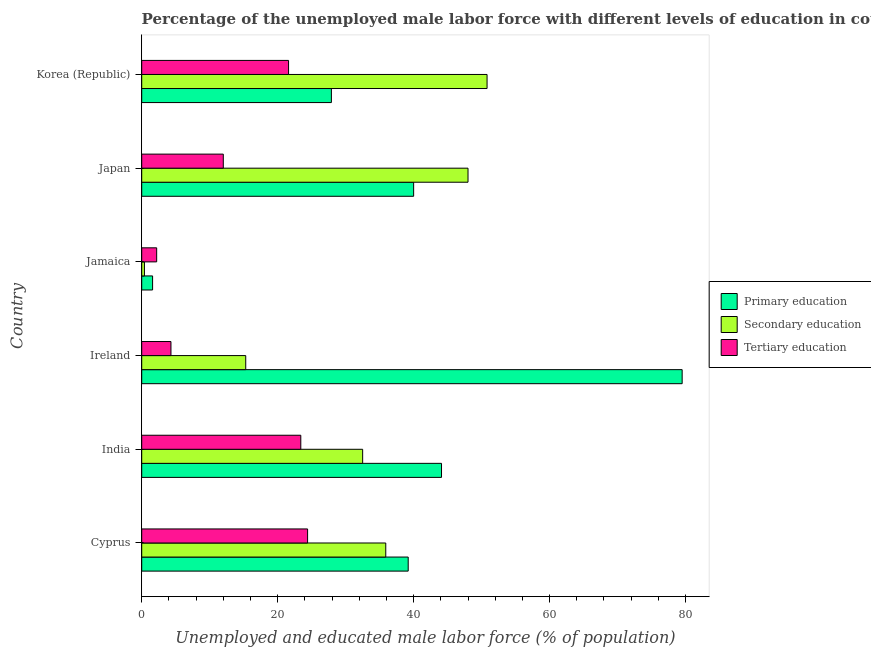How many different coloured bars are there?
Your response must be concise. 3. How many groups of bars are there?
Offer a very short reply. 6. Are the number of bars per tick equal to the number of legend labels?
Provide a succinct answer. Yes. Are the number of bars on each tick of the Y-axis equal?
Provide a succinct answer. Yes. How many bars are there on the 2nd tick from the top?
Provide a short and direct response. 3. What is the label of the 4th group of bars from the top?
Offer a very short reply. Ireland. What is the percentage of male labor force who received secondary education in Cyprus?
Provide a succinct answer. 35.9. Across all countries, what is the maximum percentage of male labor force who received secondary education?
Your answer should be very brief. 50.8. Across all countries, what is the minimum percentage of male labor force who received primary education?
Your answer should be very brief. 1.6. In which country was the percentage of male labor force who received tertiary education maximum?
Provide a short and direct response. Cyprus. In which country was the percentage of male labor force who received primary education minimum?
Your response must be concise. Jamaica. What is the total percentage of male labor force who received tertiary education in the graph?
Your response must be concise. 87.9. What is the difference between the percentage of male labor force who received tertiary education in Japan and the percentage of male labor force who received primary education in Jamaica?
Your answer should be compact. 10.4. What is the average percentage of male labor force who received tertiary education per country?
Ensure brevity in your answer.  14.65. In how many countries, is the percentage of male labor force who received primary education greater than 72 %?
Provide a succinct answer. 1. What is the ratio of the percentage of male labor force who received secondary education in Jamaica to that in Japan?
Offer a very short reply. 0.01. Is the difference between the percentage of male labor force who received tertiary education in Cyprus and Ireland greater than the difference between the percentage of male labor force who received primary education in Cyprus and Ireland?
Keep it short and to the point. Yes. What is the difference between the highest and the second highest percentage of male labor force who received primary education?
Offer a very short reply. 35.4. What is the difference between the highest and the lowest percentage of male labor force who received tertiary education?
Your response must be concise. 22.2. Is the sum of the percentage of male labor force who received primary education in Cyprus and Japan greater than the maximum percentage of male labor force who received tertiary education across all countries?
Your answer should be very brief. Yes. What does the 2nd bar from the top in India represents?
Provide a short and direct response. Secondary education. Is it the case that in every country, the sum of the percentage of male labor force who received primary education and percentage of male labor force who received secondary education is greater than the percentage of male labor force who received tertiary education?
Offer a very short reply. No. How many bars are there?
Give a very brief answer. 18. Are all the bars in the graph horizontal?
Your response must be concise. Yes. How many countries are there in the graph?
Give a very brief answer. 6. What is the difference between two consecutive major ticks on the X-axis?
Your answer should be compact. 20. Does the graph contain any zero values?
Make the answer very short. No. What is the title of the graph?
Ensure brevity in your answer.  Percentage of the unemployed male labor force with different levels of education in countries. Does "Profit Tax" appear as one of the legend labels in the graph?
Give a very brief answer. No. What is the label or title of the X-axis?
Ensure brevity in your answer.  Unemployed and educated male labor force (% of population). What is the label or title of the Y-axis?
Provide a succinct answer. Country. What is the Unemployed and educated male labor force (% of population) in Primary education in Cyprus?
Provide a short and direct response. 39.2. What is the Unemployed and educated male labor force (% of population) in Secondary education in Cyprus?
Offer a terse response. 35.9. What is the Unemployed and educated male labor force (% of population) in Tertiary education in Cyprus?
Provide a short and direct response. 24.4. What is the Unemployed and educated male labor force (% of population) of Primary education in India?
Ensure brevity in your answer.  44.1. What is the Unemployed and educated male labor force (% of population) of Secondary education in India?
Ensure brevity in your answer.  32.5. What is the Unemployed and educated male labor force (% of population) of Tertiary education in India?
Your answer should be very brief. 23.4. What is the Unemployed and educated male labor force (% of population) of Primary education in Ireland?
Your answer should be very brief. 79.5. What is the Unemployed and educated male labor force (% of population) of Secondary education in Ireland?
Make the answer very short. 15.3. What is the Unemployed and educated male labor force (% of population) of Tertiary education in Ireland?
Keep it short and to the point. 4.3. What is the Unemployed and educated male labor force (% of population) of Primary education in Jamaica?
Offer a very short reply. 1.6. What is the Unemployed and educated male labor force (% of population) of Secondary education in Jamaica?
Offer a very short reply. 0.4. What is the Unemployed and educated male labor force (% of population) of Tertiary education in Jamaica?
Your answer should be compact. 2.2. What is the Unemployed and educated male labor force (% of population) in Primary education in Japan?
Keep it short and to the point. 40. What is the Unemployed and educated male labor force (% of population) of Tertiary education in Japan?
Give a very brief answer. 12. What is the Unemployed and educated male labor force (% of population) of Primary education in Korea (Republic)?
Keep it short and to the point. 27.9. What is the Unemployed and educated male labor force (% of population) of Secondary education in Korea (Republic)?
Offer a very short reply. 50.8. What is the Unemployed and educated male labor force (% of population) in Tertiary education in Korea (Republic)?
Your answer should be compact. 21.6. Across all countries, what is the maximum Unemployed and educated male labor force (% of population) in Primary education?
Your answer should be very brief. 79.5. Across all countries, what is the maximum Unemployed and educated male labor force (% of population) of Secondary education?
Provide a short and direct response. 50.8. Across all countries, what is the maximum Unemployed and educated male labor force (% of population) in Tertiary education?
Offer a very short reply. 24.4. Across all countries, what is the minimum Unemployed and educated male labor force (% of population) in Primary education?
Keep it short and to the point. 1.6. Across all countries, what is the minimum Unemployed and educated male labor force (% of population) in Secondary education?
Offer a very short reply. 0.4. Across all countries, what is the minimum Unemployed and educated male labor force (% of population) in Tertiary education?
Offer a terse response. 2.2. What is the total Unemployed and educated male labor force (% of population) of Primary education in the graph?
Provide a succinct answer. 232.3. What is the total Unemployed and educated male labor force (% of population) of Secondary education in the graph?
Your answer should be very brief. 182.9. What is the total Unemployed and educated male labor force (% of population) in Tertiary education in the graph?
Your answer should be very brief. 87.9. What is the difference between the Unemployed and educated male labor force (% of population) in Secondary education in Cyprus and that in India?
Give a very brief answer. 3.4. What is the difference between the Unemployed and educated male labor force (% of population) in Primary education in Cyprus and that in Ireland?
Your answer should be very brief. -40.3. What is the difference between the Unemployed and educated male labor force (% of population) in Secondary education in Cyprus and that in Ireland?
Keep it short and to the point. 20.6. What is the difference between the Unemployed and educated male labor force (% of population) of Tertiary education in Cyprus and that in Ireland?
Offer a very short reply. 20.1. What is the difference between the Unemployed and educated male labor force (% of population) in Primary education in Cyprus and that in Jamaica?
Keep it short and to the point. 37.6. What is the difference between the Unemployed and educated male labor force (% of population) in Secondary education in Cyprus and that in Jamaica?
Your answer should be compact. 35.5. What is the difference between the Unemployed and educated male labor force (% of population) in Tertiary education in Cyprus and that in Jamaica?
Your answer should be very brief. 22.2. What is the difference between the Unemployed and educated male labor force (% of population) of Secondary education in Cyprus and that in Japan?
Provide a succinct answer. -12.1. What is the difference between the Unemployed and educated male labor force (% of population) in Tertiary education in Cyprus and that in Japan?
Provide a succinct answer. 12.4. What is the difference between the Unemployed and educated male labor force (% of population) in Secondary education in Cyprus and that in Korea (Republic)?
Provide a short and direct response. -14.9. What is the difference between the Unemployed and educated male labor force (% of population) of Primary education in India and that in Ireland?
Offer a very short reply. -35.4. What is the difference between the Unemployed and educated male labor force (% of population) in Secondary education in India and that in Ireland?
Keep it short and to the point. 17.2. What is the difference between the Unemployed and educated male labor force (% of population) in Primary education in India and that in Jamaica?
Offer a very short reply. 42.5. What is the difference between the Unemployed and educated male labor force (% of population) of Secondary education in India and that in Jamaica?
Provide a short and direct response. 32.1. What is the difference between the Unemployed and educated male labor force (% of population) in Tertiary education in India and that in Jamaica?
Offer a very short reply. 21.2. What is the difference between the Unemployed and educated male labor force (% of population) in Secondary education in India and that in Japan?
Your answer should be very brief. -15.5. What is the difference between the Unemployed and educated male labor force (% of population) in Tertiary education in India and that in Japan?
Give a very brief answer. 11.4. What is the difference between the Unemployed and educated male labor force (% of population) in Secondary education in India and that in Korea (Republic)?
Your response must be concise. -18.3. What is the difference between the Unemployed and educated male labor force (% of population) in Primary education in Ireland and that in Jamaica?
Offer a very short reply. 77.9. What is the difference between the Unemployed and educated male labor force (% of population) of Primary education in Ireland and that in Japan?
Ensure brevity in your answer.  39.5. What is the difference between the Unemployed and educated male labor force (% of population) in Secondary education in Ireland and that in Japan?
Give a very brief answer. -32.7. What is the difference between the Unemployed and educated male labor force (% of population) in Primary education in Ireland and that in Korea (Republic)?
Make the answer very short. 51.6. What is the difference between the Unemployed and educated male labor force (% of population) of Secondary education in Ireland and that in Korea (Republic)?
Make the answer very short. -35.5. What is the difference between the Unemployed and educated male labor force (% of population) of Tertiary education in Ireland and that in Korea (Republic)?
Provide a succinct answer. -17.3. What is the difference between the Unemployed and educated male labor force (% of population) in Primary education in Jamaica and that in Japan?
Offer a very short reply. -38.4. What is the difference between the Unemployed and educated male labor force (% of population) of Secondary education in Jamaica and that in Japan?
Your response must be concise. -47.6. What is the difference between the Unemployed and educated male labor force (% of population) of Tertiary education in Jamaica and that in Japan?
Offer a very short reply. -9.8. What is the difference between the Unemployed and educated male labor force (% of population) of Primary education in Jamaica and that in Korea (Republic)?
Make the answer very short. -26.3. What is the difference between the Unemployed and educated male labor force (% of population) in Secondary education in Jamaica and that in Korea (Republic)?
Make the answer very short. -50.4. What is the difference between the Unemployed and educated male labor force (% of population) in Tertiary education in Jamaica and that in Korea (Republic)?
Ensure brevity in your answer.  -19.4. What is the difference between the Unemployed and educated male labor force (% of population) of Tertiary education in Japan and that in Korea (Republic)?
Ensure brevity in your answer.  -9.6. What is the difference between the Unemployed and educated male labor force (% of population) in Primary education in Cyprus and the Unemployed and educated male labor force (% of population) in Secondary education in India?
Ensure brevity in your answer.  6.7. What is the difference between the Unemployed and educated male labor force (% of population) in Primary education in Cyprus and the Unemployed and educated male labor force (% of population) in Secondary education in Ireland?
Ensure brevity in your answer.  23.9. What is the difference between the Unemployed and educated male labor force (% of population) in Primary education in Cyprus and the Unemployed and educated male labor force (% of population) in Tertiary education in Ireland?
Give a very brief answer. 34.9. What is the difference between the Unemployed and educated male labor force (% of population) of Secondary education in Cyprus and the Unemployed and educated male labor force (% of population) of Tertiary education in Ireland?
Your answer should be compact. 31.6. What is the difference between the Unemployed and educated male labor force (% of population) in Primary education in Cyprus and the Unemployed and educated male labor force (% of population) in Secondary education in Jamaica?
Your answer should be compact. 38.8. What is the difference between the Unemployed and educated male labor force (% of population) of Secondary education in Cyprus and the Unemployed and educated male labor force (% of population) of Tertiary education in Jamaica?
Your answer should be very brief. 33.7. What is the difference between the Unemployed and educated male labor force (% of population) in Primary education in Cyprus and the Unemployed and educated male labor force (% of population) in Secondary education in Japan?
Keep it short and to the point. -8.8. What is the difference between the Unemployed and educated male labor force (% of population) in Primary education in Cyprus and the Unemployed and educated male labor force (% of population) in Tertiary education in Japan?
Provide a short and direct response. 27.2. What is the difference between the Unemployed and educated male labor force (% of population) of Secondary education in Cyprus and the Unemployed and educated male labor force (% of population) of Tertiary education in Japan?
Your answer should be compact. 23.9. What is the difference between the Unemployed and educated male labor force (% of population) in Primary education in Cyprus and the Unemployed and educated male labor force (% of population) in Tertiary education in Korea (Republic)?
Offer a very short reply. 17.6. What is the difference between the Unemployed and educated male labor force (% of population) in Secondary education in Cyprus and the Unemployed and educated male labor force (% of population) in Tertiary education in Korea (Republic)?
Your answer should be very brief. 14.3. What is the difference between the Unemployed and educated male labor force (% of population) of Primary education in India and the Unemployed and educated male labor force (% of population) of Secondary education in Ireland?
Provide a succinct answer. 28.8. What is the difference between the Unemployed and educated male labor force (% of population) of Primary education in India and the Unemployed and educated male labor force (% of population) of Tertiary education in Ireland?
Provide a succinct answer. 39.8. What is the difference between the Unemployed and educated male labor force (% of population) of Secondary education in India and the Unemployed and educated male labor force (% of population) of Tertiary education in Ireland?
Keep it short and to the point. 28.2. What is the difference between the Unemployed and educated male labor force (% of population) of Primary education in India and the Unemployed and educated male labor force (% of population) of Secondary education in Jamaica?
Your answer should be compact. 43.7. What is the difference between the Unemployed and educated male labor force (% of population) in Primary education in India and the Unemployed and educated male labor force (% of population) in Tertiary education in Jamaica?
Offer a very short reply. 41.9. What is the difference between the Unemployed and educated male labor force (% of population) in Secondary education in India and the Unemployed and educated male labor force (% of population) in Tertiary education in Jamaica?
Give a very brief answer. 30.3. What is the difference between the Unemployed and educated male labor force (% of population) of Primary education in India and the Unemployed and educated male labor force (% of population) of Secondary education in Japan?
Offer a terse response. -3.9. What is the difference between the Unemployed and educated male labor force (% of population) of Primary education in India and the Unemployed and educated male labor force (% of population) of Tertiary education in Japan?
Provide a succinct answer. 32.1. What is the difference between the Unemployed and educated male labor force (% of population) in Secondary education in India and the Unemployed and educated male labor force (% of population) in Tertiary education in Japan?
Your answer should be very brief. 20.5. What is the difference between the Unemployed and educated male labor force (% of population) of Primary education in Ireland and the Unemployed and educated male labor force (% of population) of Secondary education in Jamaica?
Offer a very short reply. 79.1. What is the difference between the Unemployed and educated male labor force (% of population) of Primary education in Ireland and the Unemployed and educated male labor force (% of population) of Tertiary education in Jamaica?
Ensure brevity in your answer.  77.3. What is the difference between the Unemployed and educated male labor force (% of population) in Primary education in Ireland and the Unemployed and educated male labor force (% of population) in Secondary education in Japan?
Your answer should be compact. 31.5. What is the difference between the Unemployed and educated male labor force (% of population) of Primary education in Ireland and the Unemployed and educated male labor force (% of population) of Tertiary education in Japan?
Make the answer very short. 67.5. What is the difference between the Unemployed and educated male labor force (% of population) in Secondary education in Ireland and the Unemployed and educated male labor force (% of population) in Tertiary education in Japan?
Keep it short and to the point. 3.3. What is the difference between the Unemployed and educated male labor force (% of population) of Primary education in Ireland and the Unemployed and educated male labor force (% of population) of Secondary education in Korea (Republic)?
Offer a terse response. 28.7. What is the difference between the Unemployed and educated male labor force (% of population) in Primary education in Ireland and the Unemployed and educated male labor force (% of population) in Tertiary education in Korea (Republic)?
Make the answer very short. 57.9. What is the difference between the Unemployed and educated male labor force (% of population) in Secondary education in Ireland and the Unemployed and educated male labor force (% of population) in Tertiary education in Korea (Republic)?
Give a very brief answer. -6.3. What is the difference between the Unemployed and educated male labor force (% of population) of Primary education in Jamaica and the Unemployed and educated male labor force (% of population) of Secondary education in Japan?
Ensure brevity in your answer.  -46.4. What is the difference between the Unemployed and educated male labor force (% of population) in Secondary education in Jamaica and the Unemployed and educated male labor force (% of population) in Tertiary education in Japan?
Keep it short and to the point. -11.6. What is the difference between the Unemployed and educated male labor force (% of population) of Primary education in Jamaica and the Unemployed and educated male labor force (% of population) of Secondary education in Korea (Republic)?
Offer a very short reply. -49.2. What is the difference between the Unemployed and educated male labor force (% of population) in Primary education in Jamaica and the Unemployed and educated male labor force (% of population) in Tertiary education in Korea (Republic)?
Provide a short and direct response. -20. What is the difference between the Unemployed and educated male labor force (% of population) of Secondary education in Jamaica and the Unemployed and educated male labor force (% of population) of Tertiary education in Korea (Republic)?
Your response must be concise. -21.2. What is the difference between the Unemployed and educated male labor force (% of population) of Primary education in Japan and the Unemployed and educated male labor force (% of population) of Tertiary education in Korea (Republic)?
Keep it short and to the point. 18.4. What is the difference between the Unemployed and educated male labor force (% of population) of Secondary education in Japan and the Unemployed and educated male labor force (% of population) of Tertiary education in Korea (Republic)?
Your response must be concise. 26.4. What is the average Unemployed and educated male labor force (% of population) of Primary education per country?
Your answer should be very brief. 38.72. What is the average Unemployed and educated male labor force (% of population) in Secondary education per country?
Provide a short and direct response. 30.48. What is the average Unemployed and educated male labor force (% of population) in Tertiary education per country?
Your answer should be compact. 14.65. What is the difference between the Unemployed and educated male labor force (% of population) in Primary education and Unemployed and educated male labor force (% of population) in Secondary education in Cyprus?
Your response must be concise. 3.3. What is the difference between the Unemployed and educated male labor force (% of population) in Primary education and Unemployed and educated male labor force (% of population) in Tertiary education in Cyprus?
Keep it short and to the point. 14.8. What is the difference between the Unemployed and educated male labor force (% of population) in Secondary education and Unemployed and educated male labor force (% of population) in Tertiary education in Cyprus?
Your response must be concise. 11.5. What is the difference between the Unemployed and educated male labor force (% of population) in Primary education and Unemployed and educated male labor force (% of population) in Secondary education in India?
Offer a very short reply. 11.6. What is the difference between the Unemployed and educated male labor force (% of population) of Primary education and Unemployed and educated male labor force (% of population) of Tertiary education in India?
Keep it short and to the point. 20.7. What is the difference between the Unemployed and educated male labor force (% of population) of Primary education and Unemployed and educated male labor force (% of population) of Secondary education in Ireland?
Ensure brevity in your answer.  64.2. What is the difference between the Unemployed and educated male labor force (% of population) of Primary education and Unemployed and educated male labor force (% of population) of Tertiary education in Ireland?
Your answer should be compact. 75.2. What is the difference between the Unemployed and educated male labor force (% of population) in Secondary education and Unemployed and educated male labor force (% of population) in Tertiary education in Ireland?
Your answer should be compact. 11. What is the difference between the Unemployed and educated male labor force (% of population) in Primary education and Unemployed and educated male labor force (% of population) in Secondary education in Jamaica?
Give a very brief answer. 1.2. What is the difference between the Unemployed and educated male labor force (% of population) in Primary education and Unemployed and educated male labor force (% of population) in Tertiary education in Jamaica?
Your answer should be compact. -0.6. What is the difference between the Unemployed and educated male labor force (% of population) in Primary education and Unemployed and educated male labor force (% of population) in Secondary education in Japan?
Provide a short and direct response. -8. What is the difference between the Unemployed and educated male labor force (% of population) of Primary education and Unemployed and educated male labor force (% of population) of Tertiary education in Japan?
Offer a terse response. 28. What is the difference between the Unemployed and educated male labor force (% of population) in Primary education and Unemployed and educated male labor force (% of population) in Secondary education in Korea (Republic)?
Make the answer very short. -22.9. What is the difference between the Unemployed and educated male labor force (% of population) in Primary education and Unemployed and educated male labor force (% of population) in Tertiary education in Korea (Republic)?
Your response must be concise. 6.3. What is the difference between the Unemployed and educated male labor force (% of population) of Secondary education and Unemployed and educated male labor force (% of population) of Tertiary education in Korea (Republic)?
Make the answer very short. 29.2. What is the ratio of the Unemployed and educated male labor force (% of population) in Secondary education in Cyprus to that in India?
Ensure brevity in your answer.  1.1. What is the ratio of the Unemployed and educated male labor force (% of population) of Tertiary education in Cyprus to that in India?
Provide a succinct answer. 1.04. What is the ratio of the Unemployed and educated male labor force (% of population) in Primary education in Cyprus to that in Ireland?
Offer a terse response. 0.49. What is the ratio of the Unemployed and educated male labor force (% of population) in Secondary education in Cyprus to that in Ireland?
Offer a very short reply. 2.35. What is the ratio of the Unemployed and educated male labor force (% of population) of Tertiary education in Cyprus to that in Ireland?
Your answer should be compact. 5.67. What is the ratio of the Unemployed and educated male labor force (% of population) in Primary education in Cyprus to that in Jamaica?
Ensure brevity in your answer.  24.5. What is the ratio of the Unemployed and educated male labor force (% of population) of Secondary education in Cyprus to that in Jamaica?
Offer a very short reply. 89.75. What is the ratio of the Unemployed and educated male labor force (% of population) in Tertiary education in Cyprus to that in Jamaica?
Your answer should be compact. 11.09. What is the ratio of the Unemployed and educated male labor force (% of population) in Secondary education in Cyprus to that in Japan?
Your response must be concise. 0.75. What is the ratio of the Unemployed and educated male labor force (% of population) of Tertiary education in Cyprus to that in Japan?
Your answer should be very brief. 2.03. What is the ratio of the Unemployed and educated male labor force (% of population) in Primary education in Cyprus to that in Korea (Republic)?
Your answer should be compact. 1.41. What is the ratio of the Unemployed and educated male labor force (% of population) of Secondary education in Cyprus to that in Korea (Republic)?
Offer a very short reply. 0.71. What is the ratio of the Unemployed and educated male labor force (% of population) in Tertiary education in Cyprus to that in Korea (Republic)?
Your answer should be compact. 1.13. What is the ratio of the Unemployed and educated male labor force (% of population) of Primary education in India to that in Ireland?
Offer a very short reply. 0.55. What is the ratio of the Unemployed and educated male labor force (% of population) of Secondary education in India to that in Ireland?
Keep it short and to the point. 2.12. What is the ratio of the Unemployed and educated male labor force (% of population) of Tertiary education in India to that in Ireland?
Keep it short and to the point. 5.44. What is the ratio of the Unemployed and educated male labor force (% of population) in Primary education in India to that in Jamaica?
Offer a terse response. 27.56. What is the ratio of the Unemployed and educated male labor force (% of population) of Secondary education in India to that in Jamaica?
Your answer should be compact. 81.25. What is the ratio of the Unemployed and educated male labor force (% of population) of Tertiary education in India to that in Jamaica?
Offer a very short reply. 10.64. What is the ratio of the Unemployed and educated male labor force (% of population) of Primary education in India to that in Japan?
Your response must be concise. 1.1. What is the ratio of the Unemployed and educated male labor force (% of population) of Secondary education in India to that in Japan?
Offer a terse response. 0.68. What is the ratio of the Unemployed and educated male labor force (% of population) in Tertiary education in India to that in Japan?
Give a very brief answer. 1.95. What is the ratio of the Unemployed and educated male labor force (% of population) of Primary education in India to that in Korea (Republic)?
Make the answer very short. 1.58. What is the ratio of the Unemployed and educated male labor force (% of population) in Secondary education in India to that in Korea (Republic)?
Offer a very short reply. 0.64. What is the ratio of the Unemployed and educated male labor force (% of population) of Tertiary education in India to that in Korea (Republic)?
Offer a very short reply. 1.08. What is the ratio of the Unemployed and educated male labor force (% of population) of Primary education in Ireland to that in Jamaica?
Your answer should be very brief. 49.69. What is the ratio of the Unemployed and educated male labor force (% of population) of Secondary education in Ireland to that in Jamaica?
Make the answer very short. 38.25. What is the ratio of the Unemployed and educated male labor force (% of population) in Tertiary education in Ireland to that in Jamaica?
Make the answer very short. 1.95. What is the ratio of the Unemployed and educated male labor force (% of population) in Primary education in Ireland to that in Japan?
Your response must be concise. 1.99. What is the ratio of the Unemployed and educated male labor force (% of population) in Secondary education in Ireland to that in Japan?
Your response must be concise. 0.32. What is the ratio of the Unemployed and educated male labor force (% of population) of Tertiary education in Ireland to that in Japan?
Offer a terse response. 0.36. What is the ratio of the Unemployed and educated male labor force (% of population) of Primary education in Ireland to that in Korea (Republic)?
Your answer should be compact. 2.85. What is the ratio of the Unemployed and educated male labor force (% of population) in Secondary education in Ireland to that in Korea (Republic)?
Keep it short and to the point. 0.3. What is the ratio of the Unemployed and educated male labor force (% of population) of Tertiary education in Ireland to that in Korea (Republic)?
Make the answer very short. 0.2. What is the ratio of the Unemployed and educated male labor force (% of population) of Secondary education in Jamaica to that in Japan?
Make the answer very short. 0.01. What is the ratio of the Unemployed and educated male labor force (% of population) of Tertiary education in Jamaica to that in Japan?
Your answer should be compact. 0.18. What is the ratio of the Unemployed and educated male labor force (% of population) of Primary education in Jamaica to that in Korea (Republic)?
Your response must be concise. 0.06. What is the ratio of the Unemployed and educated male labor force (% of population) in Secondary education in Jamaica to that in Korea (Republic)?
Offer a very short reply. 0.01. What is the ratio of the Unemployed and educated male labor force (% of population) of Tertiary education in Jamaica to that in Korea (Republic)?
Your answer should be compact. 0.1. What is the ratio of the Unemployed and educated male labor force (% of population) in Primary education in Japan to that in Korea (Republic)?
Give a very brief answer. 1.43. What is the ratio of the Unemployed and educated male labor force (% of population) of Secondary education in Japan to that in Korea (Republic)?
Your answer should be very brief. 0.94. What is the ratio of the Unemployed and educated male labor force (% of population) in Tertiary education in Japan to that in Korea (Republic)?
Keep it short and to the point. 0.56. What is the difference between the highest and the second highest Unemployed and educated male labor force (% of population) of Primary education?
Ensure brevity in your answer.  35.4. What is the difference between the highest and the second highest Unemployed and educated male labor force (% of population) of Tertiary education?
Make the answer very short. 1. What is the difference between the highest and the lowest Unemployed and educated male labor force (% of population) in Primary education?
Offer a very short reply. 77.9. What is the difference between the highest and the lowest Unemployed and educated male labor force (% of population) of Secondary education?
Your response must be concise. 50.4. 